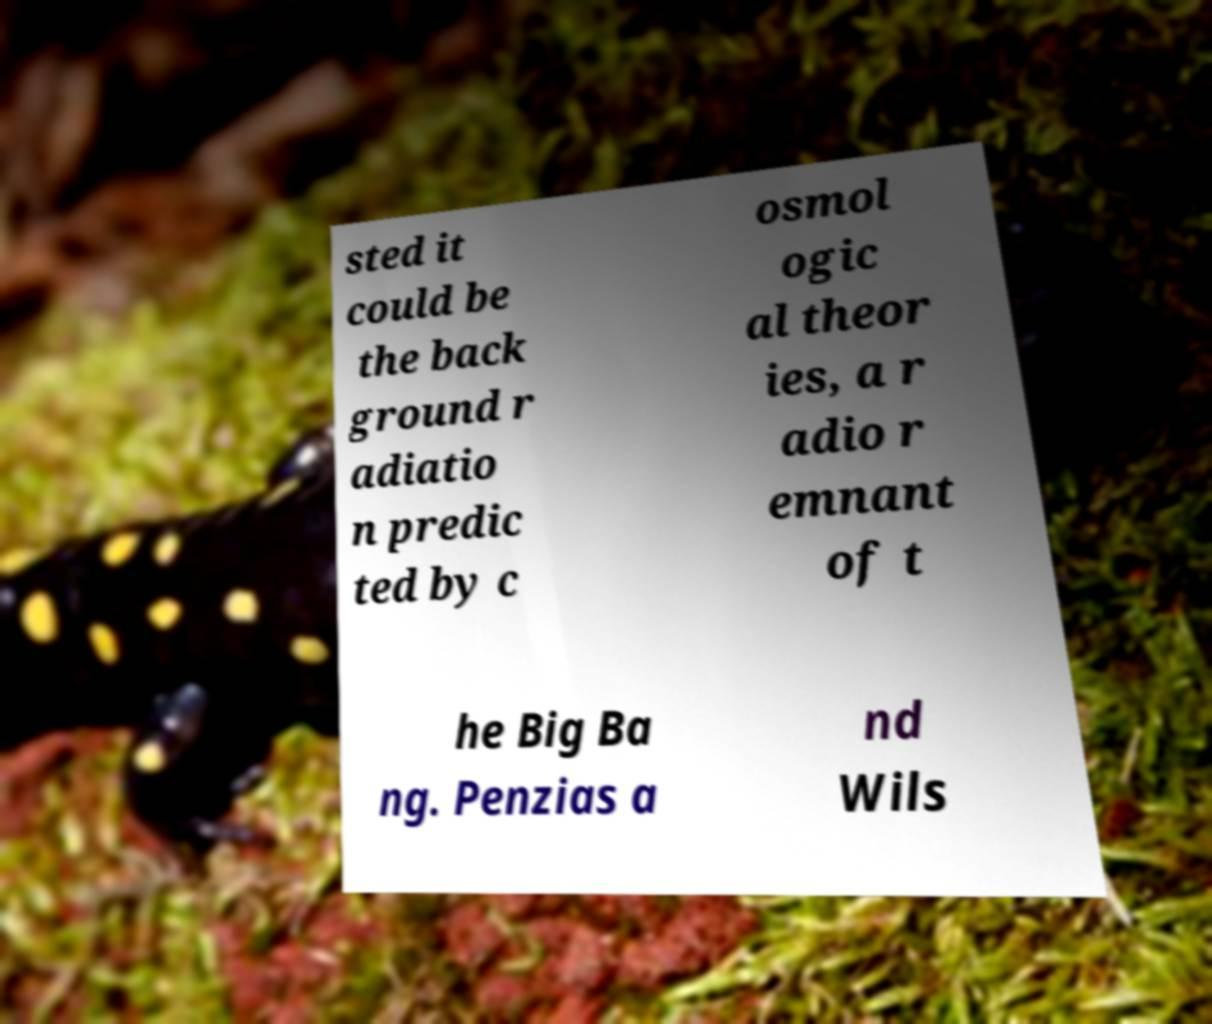Can you accurately transcribe the text from the provided image for me? sted it could be the back ground r adiatio n predic ted by c osmol ogic al theor ies, a r adio r emnant of t he Big Ba ng. Penzias a nd Wils 